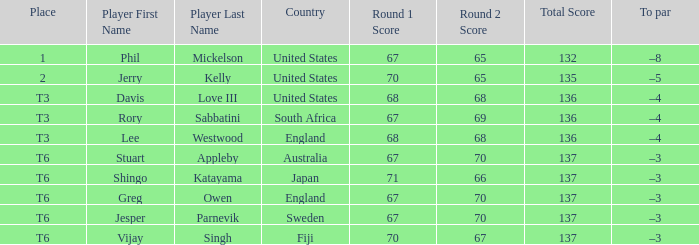Name the player for fiji Vijay Singh. 